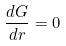Convert formula to latex. <formula><loc_0><loc_0><loc_500><loc_500>\frac { d G } { d r } = 0</formula> 